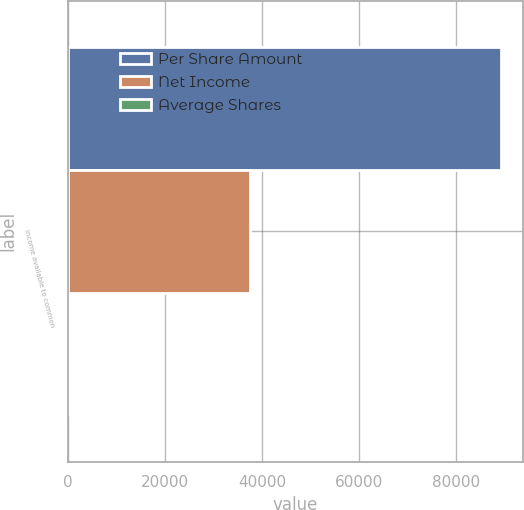Convert chart to OTSL. <chart><loc_0><loc_0><loc_500><loc_500><stacked_bar_chart><ecel><fcel>Income available to common<nl><fcel>Per Share Amount<fcel>89385<nl><fcel>Net Income<fcel>37615<nl><fcel>Average Shares<fcel>2.38<nl></chart> 